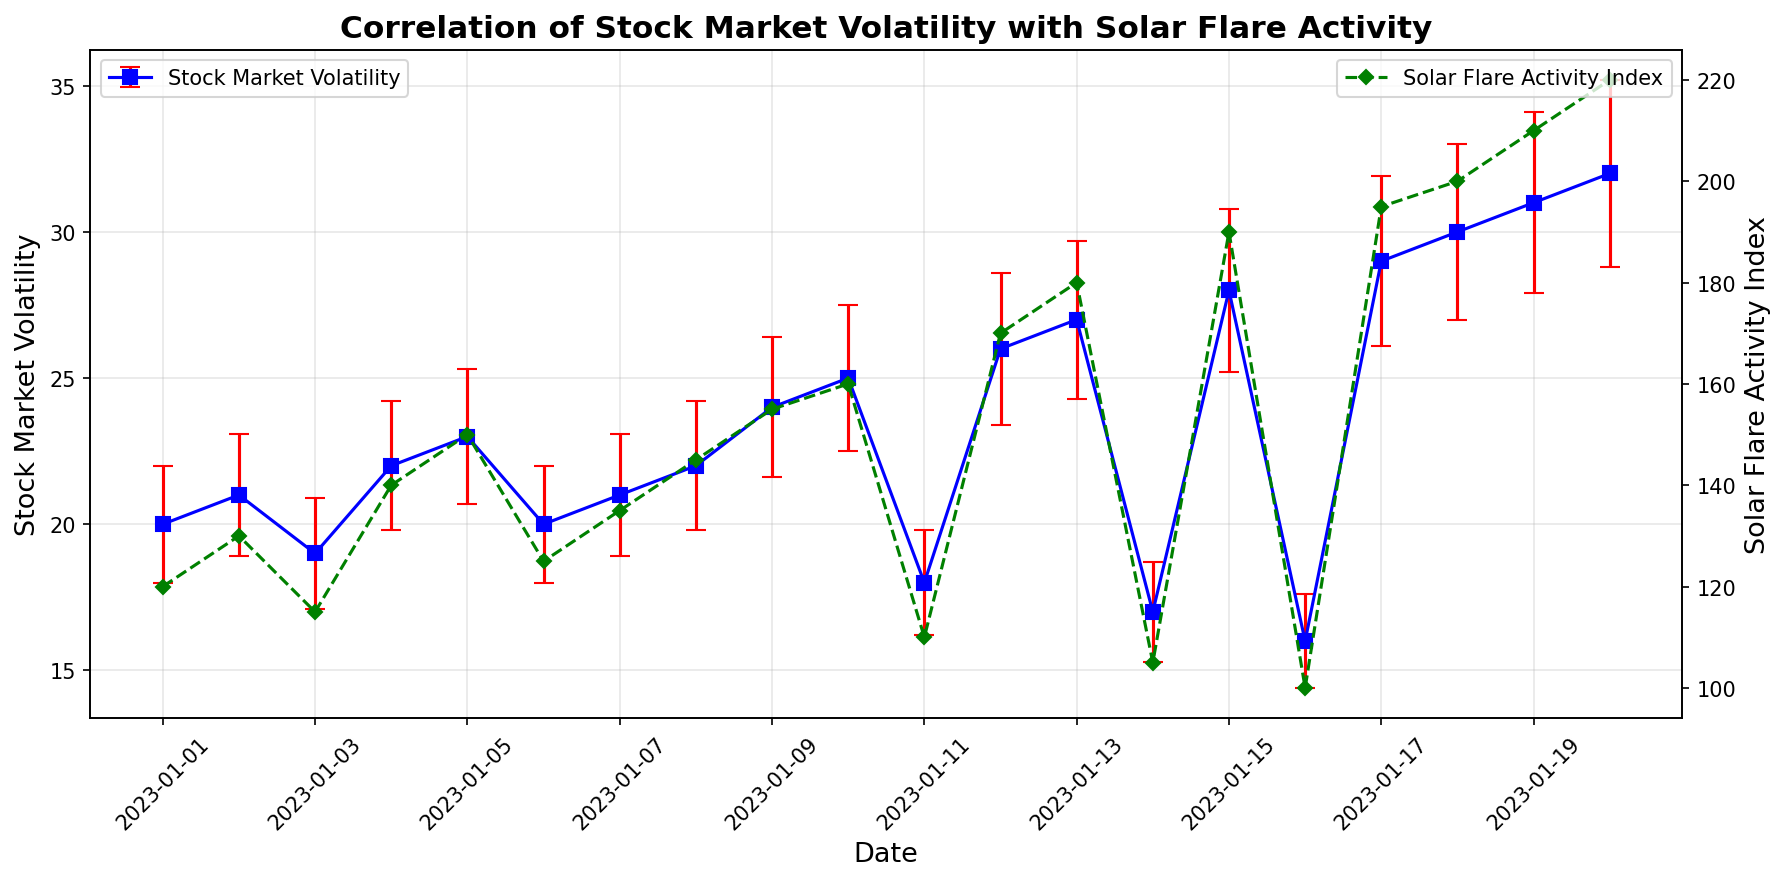What is the general trend of stock market volatility from January 1 to January 20, 2023? By observing the plot, the stock market volatility generally increases from January 1 (volatility around 20) to January 20 (volatility around 32). This trend is clear from the upward movement of the blue points and lines.
Answer: Increasing Does the solar flare activity index correlate with the stock market volatility? By observing both the blue line for stock market volatility and the green line for the solar flare activity index, it seems that both lines trend upward simultaneously, suggesting a positive correlation. As solar flare activity increases, stock market volatility also increases.
Answer: Positive correlation On which date is the stock market volatility highest, and what is its value? The stock market volatility is represented by the blue points and lines. The highest value appears on January 20, 2023, with a volatility of 32.
Answer: January 20, 32 How many days show an increase in both solar flare activity index and stock market volatility compared to the previous day? By observing the plot, we need to count the days where both the blue and green lines/points show an increase compared to the previous days. This happens on January 2, 4, 5, 8, 9, 10, 12, 13, 15, 17, 18, 19, and 20.
Answer: 13 days Which color represents the solar flare activity index in the plot? Just by looking at the plot, the solar flare activity index is represented by the green color and dashed lines with diamond markers.
Answer: Green What is the difference in stock market volatility between January 1 and January 20? On January 1, the stock market volatility is around 20, and on January 20, it is around 32. The difference is calculated as 32 - 20.
Answer: 12 On which date is the volatility error the smallest, and what is its value? The volatility error bars are visible as red caps on the blue points. The smallest error appears on January 16, with a value of 1.6.
Answer: January 16, 1.6 What's the average stock market volatility over the plotted dates? Sum of all stock market volatility values divided by the number of dates: (20+21+19+22+23+20+21+22+24+25+18+26+27+17+28+16+29+30+31+32)/20 = 23.15.
Answer: 23.15 Which day(s) have a solar flare activity index of exactly 180? By looking at the green line and markers, the solar flare activity index reaches 180 on January 13.
Answer: January 13 Are there more days with solar flare activity above or below 150? Observing the green line, there are more days with solar flare activity above 150 (January 9 to January 20) compared to those below 150 (January 1 to January 8).
Answer: Above 150 